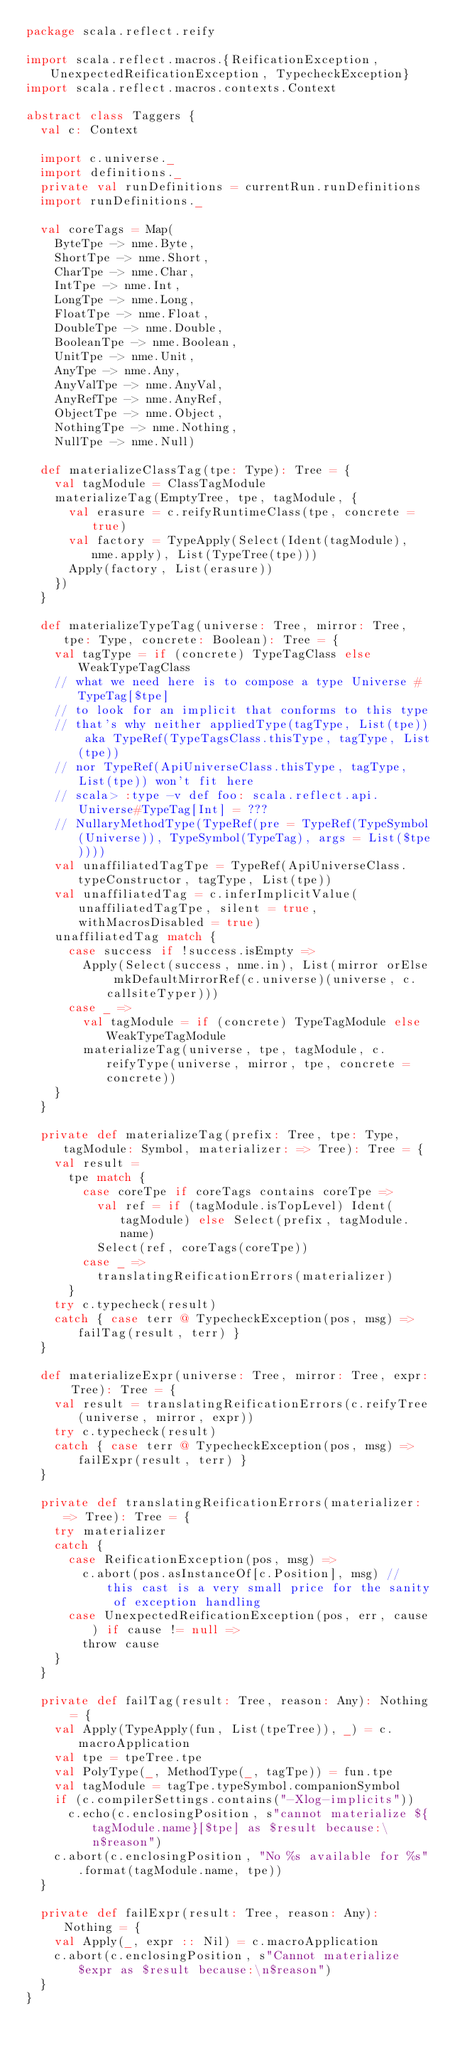Convert code to text. <code><loc_0><loc_0><loc_500><loc_500><_Scala_>package scala.reflect.reify

import scala.reflect.macros.{ReificationException, UnexpectedReificationException, TypecheckException}
import scala.reflect.macros.contexts.Context

abstract class Taggers {
  val c: Context

  import c.universe._
  import definitions._
  private val runDefinitions = currentRun.runDefinitions
  import runDefinitions._

  val coreTags = Map(
    ByteTpe -> nme.Byte,
    ShortTpe -> nme.Short,
    CharTpe -> nme.Char,
    IntTpe -> nme.Int,
    LongTpe -> nme.Long,
    FloatTpe -> nme.Float,
    DoubleTpe -> nme.Double,
    BooleanTpe -> nme.Boolean,
    UnitTpe -> nme.Unit,
    AnyTpe -> nme.Any,
    AnyValTpe -> nme.AnyVal,
    AnyRefTpe -> nme.AnyRef,
    ObjectTpe -> nme.Object,
    NothingTpe -> nme.Nothing,
    NullTpe -> nme.Null)

  def materializeClassTag(tpe: Type): Tree = {
    val tagModule = ClassTagModule
    materializeTag(EmptyTree, tpe, tagModule, {
      val erasure = c.reifyRuntimeClass(tpe, concrete = true)
      val factory = TypeApply(Select(Ident(tagModule), nme.apply), List(TypeTree(tpe)))
      Apply(factory, List(erasure))
    })
  }

  def materializeTypeTag(universe: Tree, mirror: Tree, tpe: Type, concrete: Boolean): Tree = {
    val tagType = if (concrete) TypeTagClass else WeakTypeTagClass
    // what we need here is to compose a type Universe # TypeTag[$tpe]
    // to look for an implicit that conforms to this type
    // that's why neither appliedType(tagType, List(tpe)) aka TypeRef(TypeTagsClass.thisType, tagType, List(tpe))
    // nor TypeRef(ApiUniverseClass.thisType, tagType, List(tpe)) won't fit here
    // scala> :type -v def foo: scala.reflect.api.Universe#TypeTag[Int] = ???
    // NullaryMethodType(TypeRef(pre = TypeRef(TypeSymbol(Universe)), TypeSymbol(TypeTag), args = List($tpe))))
    val unaffiliatedTagTpe = TypeRef(ApiUniverseClass.typeConstructor, tagType, List(tpe))
    val unaffiliatedTag = c.inferImplicitValue(unaffiliatedTagTpe, silent = true, withMacrosDisabled = true)
    unaffiliatedTag match {
      case success if !success.isEmpty =>
        Apply(Select(success, nme.in), List(mirror orElse mkDefaultMirrorRef(c.universe)(universe, c.callsiteTyper)))
      case _ =>
        val tagModule = if (concrete) TypeTagModule else WeakTypeTagModule
        materializeTag(universe, tpe, tagModule, c.reifyType(universe, mirror, tpe, concrete = concrete))
    }
  }

  private def materializeTag(prefix: Tree, tpe: Type, tagModule: Symbol, materializer: => Tree): Tree = {
    val result =
      tpe match {
        case coreTpe if coreTags contains coreTpe =>
          val ref = if (tagModule.isTopLevel) Ident(tagModule) else Select(prefix, tagModule.name)
          Select(ref, coreTags(coreTpe))
        case _ =>
          translatingReificationErrors(materializer)
      }
    try c.typecheck(result)
    catch { case terr @ TypecheckException(pos, msg) => failTag(result, terr) }
  }

  def materializeExpr(universe: Tree, mirror: Tree, expr: Tree): Tree = {
    val result = translatingReificationErrors(c.reifyTree(universe, mirror, expr))
    try c.typecheck(result)
    catch { case terr @ TypecheckException(pos, msg) => failExpr(result, terr) }
  }

  private def translatingReificationErrors(materializer: => Tree): Tree = {
    try materializer
    catch {
      case ReificationException(pos, msg) =>
        c.abort(pos.asInstanceOf[c.Position], msg) // this cast is a very small price for the sanity of exception handling
      case UnexpectedReificationException(pos, err, cause) if cause != null =>
        throw cause
    }
  }

  private def failTag(result: Tree, reason: Any): Nothing = {
    val Apply(TypeApply(fun, List(tpeTree)), _) = c.macroApplication
    val tpe = tpeTree.tpe
    val PolyType(_, MethodType(_, tagTpe)) = fun.tpe
    val tagModule = tagTpe.typeSymbol.companionSymbol
    if (c.compilerSettings.contains("-Xlog-implicits"))
      c.echo(c.enclosingPosition, s"cannot materialize ${tagModule.name}[$tpe] as $result because:\n$reason")
    c.abort(c.enclosingPosition, "No %s available for %s".format(tagModule.name, tpe))
  }

  private def failExpr(result: Tree, reason: Any): Nothing = {
    val Apply(_, expr :: Nil) = c.macroApplication
    c.abort(c.enclosingPosition, s"Cannot materialize $expr as $result because:\n$reason")
  }
}
</code> 